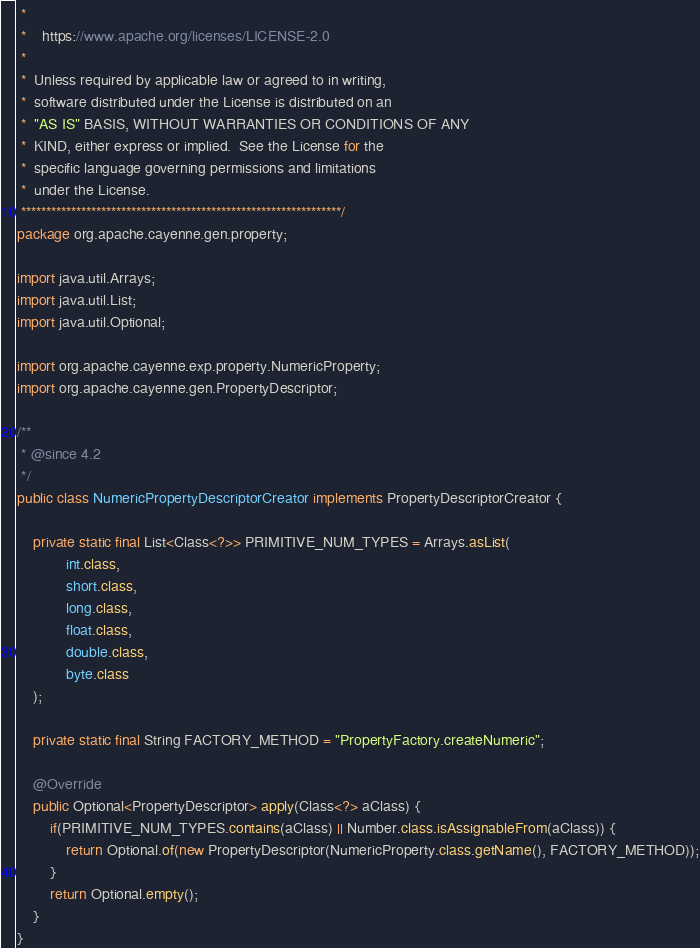<code> <loc_0><loc_0><loc_500><loc_500><_Java_> *
 *    https://www.apache.org/licenses/LICENSE-2.0
 *
 *  Unless required by applicable law or agreed to in writing,
 *  software distributed under the License is distributed on an
 *  "AS IS" BASIS, WITHOUT WARRANTIES OR CONDITIONS OF ANY
 *  KIND, either express or implied.  See the License for the
 *  specific language governing permissions and limitations
 *  under the License.
 ****************************************************************/
package org.apache.cayenne.gen.property;

import java.util.Arrays;
import java.util.List;
import java.util.Optional;

import org.apache.cayenne.exp.property.NumericProperty;
import org.apache.cayenne.gen.PropertyDescriptor;

/**
 * @since 4.2
 */
public class NumericPropertyDescriptorCreator implements PropertyDescriptorCreator {

    private static final List<Class<?>> PRIMITIVE_NUM_TYPES = Arrays.asList(
            int.class,
            short.class,
            long.class,
            float.class,
            double.class,
            byte.class
    );

    private static final String FACTORY_METHOD = "PropertyFactory.createNumeric";

    @Override
    public Optional<PropertyDescriptor> apply(Class<?> aClass) {
        if(PRIMITIVE_NUM_TYPES.contains(aClass) || Number.class.isAssignableFrom(aClass)) {
            return Optional.of(new PropertyDescriptor(NumericProperty.class.getName(), FACTORY_METHOD));
        }
        return Optional.empty();
    }
}
</code> 